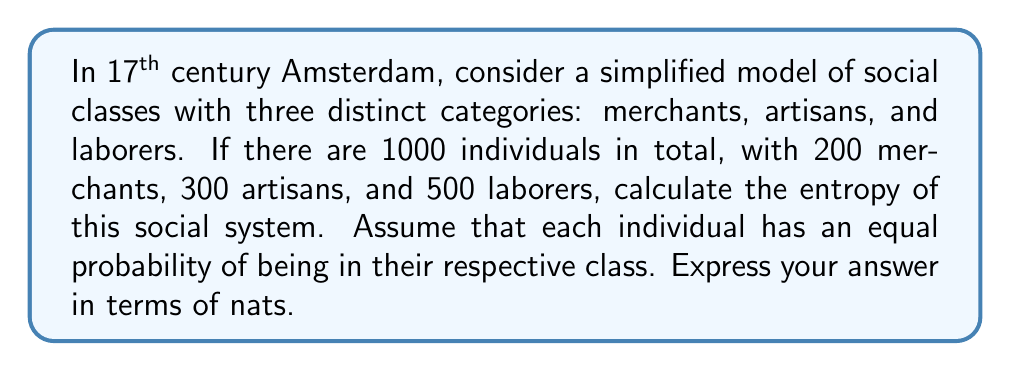Provide a solution to this math problem. To calculate the entropy of this social system, we'll use the Shannon entropy formula:

$$S = -\sum_{i} p_i \ln(p_i)$$

Where $p_i$ is the probability of an individual belonging to class $i$.

Step 1: Calculate the probabilities for each class
$p_{merchants} = \frac{200}{1000} = 0.2$
$p_{artisans} = \frac{300}{1000} = 0.3$
$p_{laborers} = \frac{500}{1000} = 0.5$

Step 2: Apply the entropy formula
$$\begin{align*}
S &= -[p_{merchants} \ln(p_{merchants}) + p_{artisans} \ln(p_{artisans}) + p_{laborers} \ln(p_{laborers})] \\
&= -[0.2 \ln(0.2) + 0.3 \ln(0.3) + 0.5 \ln(0.5)] \\
&= -[0.2 \times (-1.6094) + 0.3 \times (-1.2040) + 0.5 \times (-0.6931)] \\
&= -[-0.3219 - 0.3612 - 0.3466] \\
&= 1.0297
\end{align*}$$

Step 3: Interpret the result
The entropy of 1.0297 nats indicates the degree of social diversity or "mixedness" in this simplified model of 17th century Amsterdam society. A higher entropy would suggest a more evenly distributed social structure, while a lower entropy would indicate a more stratified society.
Answer: 1.0297 nats 